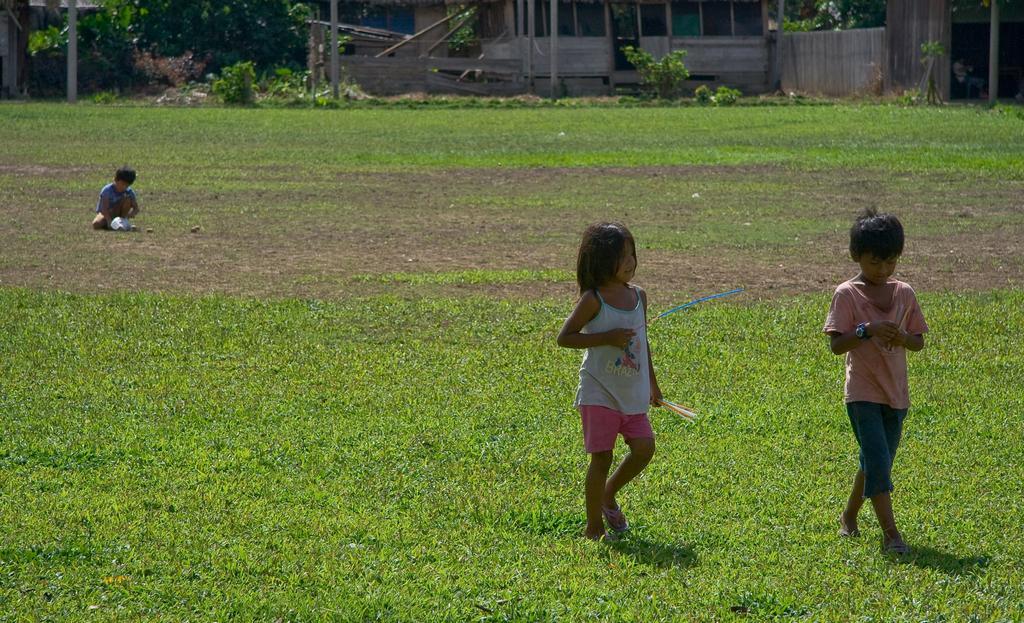Can you describe this image briefly? In this image, I can see a boy and a girl walking. This is a grass. Here is a boy sitting. In the background, that looks like a house. I can see the trees and plants. I think this is a pole. 